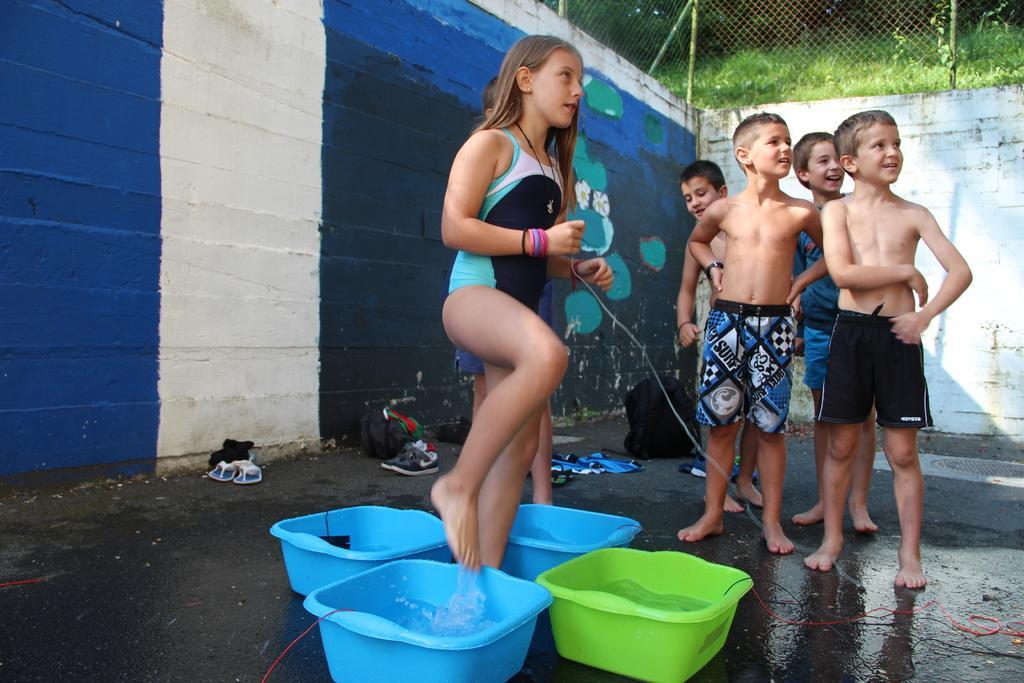Can you describe this image briefly? In this image there are kids, in the bottom there are trays in that trays there is water, in the background there is a wall on top of the wall there is fencing and grassland. 